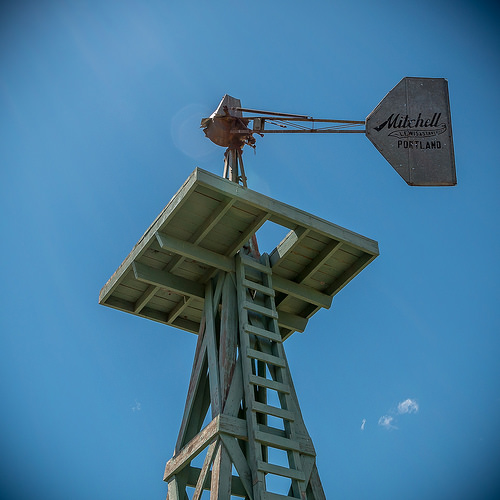<image>
Is there a windmill on the tower? Yes. Looking at the image, I can see the windmill is positioned on top of the tower, with the tower providing support. Is there a sky behind the tower? Yes. From this viewpoint, the sky is positioned behind the tower, with the tower partially or fully occluding the sky. 